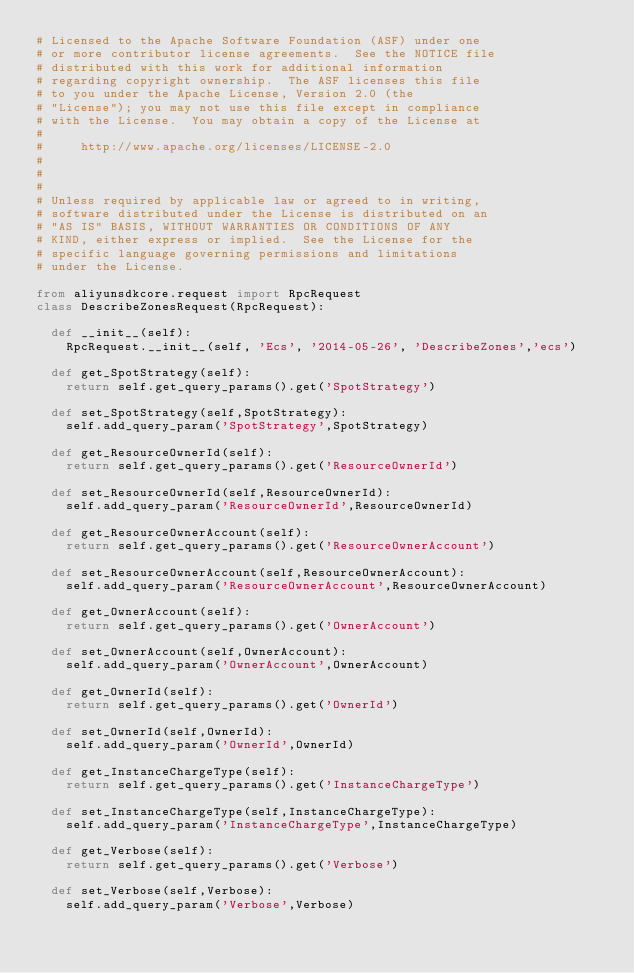<code> <loc_0><loc_0><loc_500><loc_500><_Python_># Licensed to the Apache Software Foundation (ASF) under one
# or more contributor license agreements.  See the NOTICE file
# distributed with this work for additional information
# regarding copyright ownership.  The ASF licenses this file
# to you under the Apache License, Version 2.0 (the
# "License"); you may not use this file except in compliance
# with the License.  You may obtain a copy of the License at
#
#     http://www.apache.org/licenses/LICENSE-2.0
#
#
#
# Unless required by applicable law or agreed to in writing,
# software distributed under the License is distributed on an
# "AS IS" BASIS, WITHOUT WARRANTIES OR CONDITIONS OF ANY
# KIND, either express or implied.  See the License for the
# specific language governing permissions and limitations
# under the License.

from aliyunsdkcore.request import RpcRequest
class DescribeZonesRequest(RpcRequest):

	def __init__(self):
		RpcRequest.__init__(self, 'Ecs', '2014-05-26', 'DescribeZones','ecs')

	def get_SpotStrategy(self):
		return self.get_query_params().get('SpotStrategy')

	def set_SpotStrategy(self,SpotStrategy):
		self.add_query_param('SpotStrategy',SpotStrategy)

	def get_ResourceOwnerId(self):
		return self.get_query_params().get('ResourceOwnerId')

	def set_ResourceOwnerId(self,ResourceOwnerId):
		self.add_query_param('ResourceOwnerId',ResourceOwnerId)

	def get_ResourceOwnerAccount(self):
		return self.get_query_params().get('ResourceOwnerAccount')

	def set_ResourceOwnerAccount(self,ResourceOwnerAccount):
		self.add_query_param('ResourceOwnerAccount',ResourceOwnerAccount)

	def get_OwnerAccount(self):
		return self.get_query_params().get('OwnerAccount')

	def set_OwnerAccount(self,OwnerAccount):
		self.add_query_param('OwnerAccount',OwnerAccount)

	def get_OwnerId(self):
		return self.get_query_params().get('OwnerId')

	def set_OwnerId(self,OwnerId):
		self.add_query_param('OwnerId',OwnerId)

	def get_InstanceChargeType(self):
		return self.get_query_params().get('InstanceChargeType')

	def set_InstanceChargeType(self,InstanceChargeType):
		self.add_query_param('InstanceChargeType',InstanceChargeType)

	def get_Verbose(self):
		return self.get_query_params().get('Verbose')

	def set_Verbose(self,Verbose):
		self.add_query_param('Verbose',Verbose)</code> 